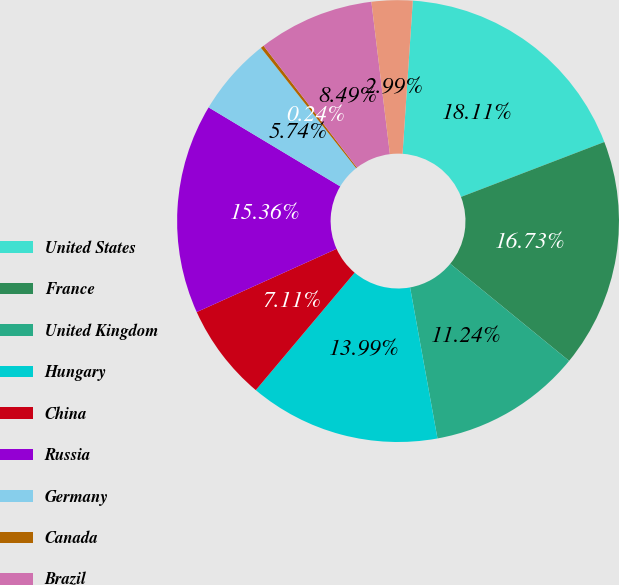<chart> <loc_0><loc_0><loc_500><loc_500><pie_chart><fcel>United States<fcel>France<fcel>United Kingdom<fcel>Hungary<fcel>China<fcel>Russia<fcel>Germany<fcel>Canada<fcel>Brazil<fcel>Japan<nl><fcel>18.11%<fcel>16.73%<fcel>11.24%<fcel>13.99%<fcel>7.11%<fcel>15.36%<fcel>5.74%<fcel>0.24%<fcel>8.49%<fcel>2.99%<nl></chart> 